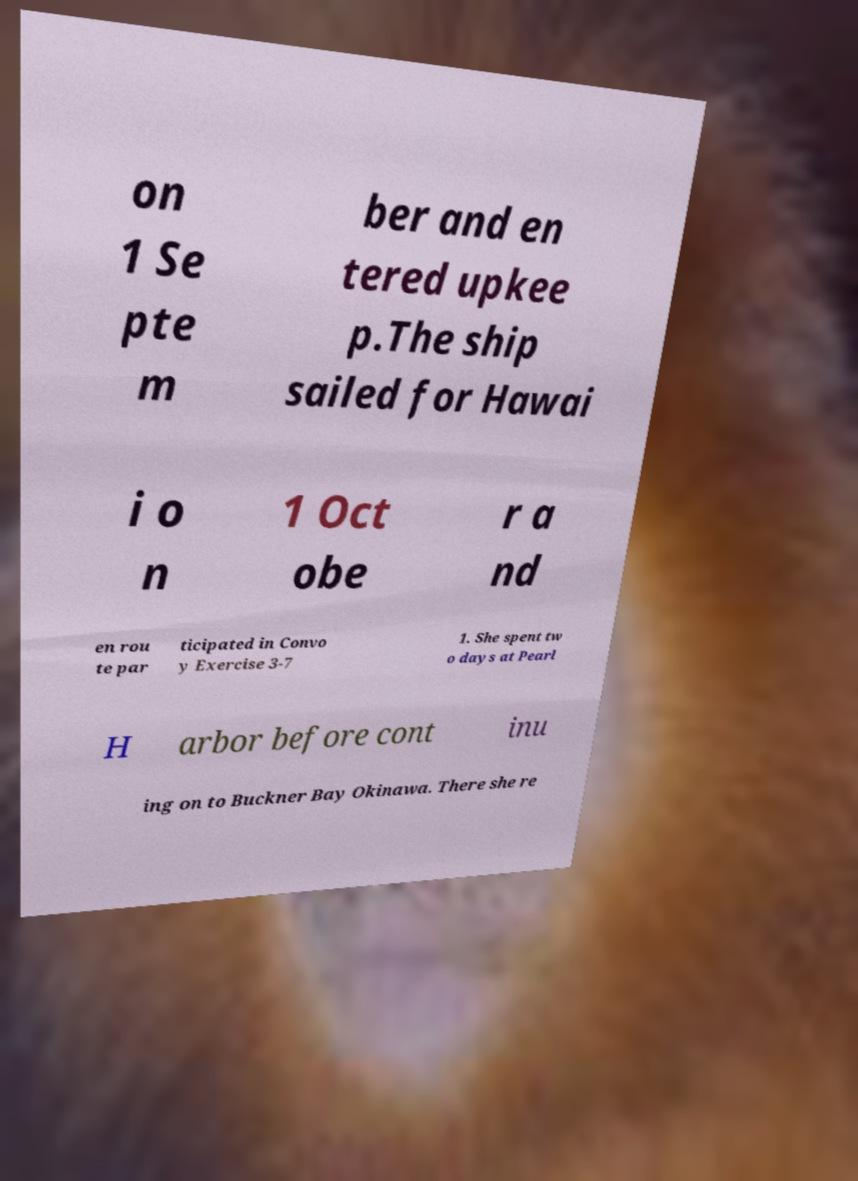Can you read and provide the text displayed in the image?This photo seems to have some interesting text. Can you extract and type it out for me? on 1 Se pte m ber and en tered upkee p.The ship sailed for Hawai i o n 1 Oct obe r a nd en rou te par ticipated in Convo y Exercise 3-7 1. She spent tw o days at Pearl H arbor before cont inu ing on to Buckner Bay Okinawa. There she re 